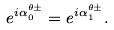<formula> <loc_0><loc_0><loc_500><loc_500>e ^ { i \alpha ^ { \theta \pm } _ { 0 } } = e ^ { i \alpha ^ { \theta \pm } _ { 1 } } .</formula> 